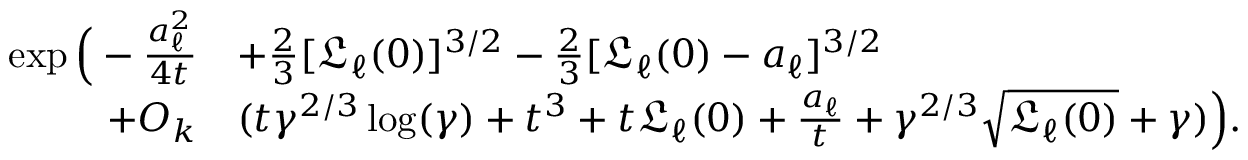<formula> <loc_0><loc_0><loc_500><loc_500>\begin{array} { r l } { \exp \left ( - \frac { a _ { \ell } ^ { 2 } } { 4 t } } & { + \frac { 2 } { 3 } [ \mathfrak { L } _ { \ell } ( 0 ) ] ^ { 3 / 2 } - \frac { 2 } { 3 } [ \mathfrak { L } _ { \ell } ( 0 ) - a _ { \ell } ] ^ { 3 / 2 } } \\ { + O _ { k } } & { ( t \gamma ^ { 2 / 3 } \log ( \gamma ) + t ^ { 3 } + t \mathfrak { L } _ { \ell } ( 0 ) + \frac { a _ { \ell } } { t } + \gamma ^ { 2 / 3 } \sqrt { \mathfrak { L } _ { \ell } ( 0 ) } + \gamma ) \right ) . } \end{array}</formula> 